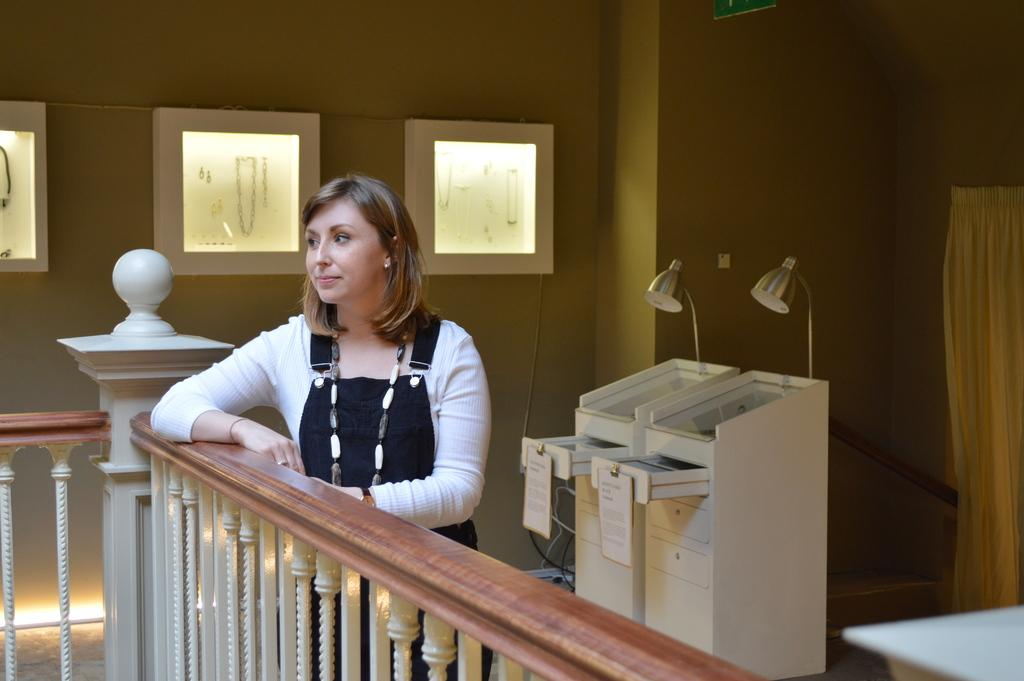Who is the main subject in the image? There is a woman in the image. What is the woman doing in the image? The woman is standing. What can be seen in the background of the image? There is a wall and jewelry boxes in the background of the image. What is the woman's reaction to the surprise in the image? There is no indication of a surprise in the image, so it is not possible to determine the woman's reaction. 